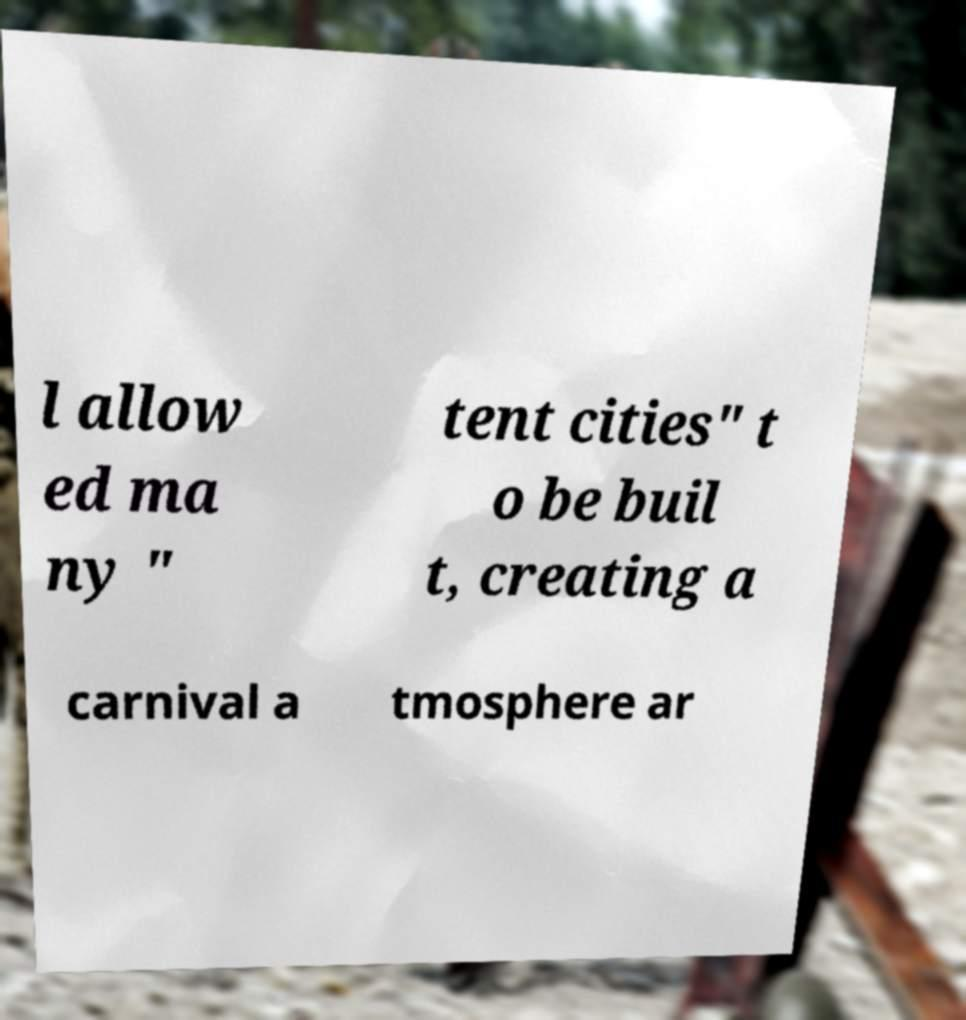Can you read and provide the text displayed in the image?This photo seems to have some interesting text. Can you extract and type it out for me? l allow ed ma ny " tent cities" t o be buil t, creating a carnival a tmosphere ar 